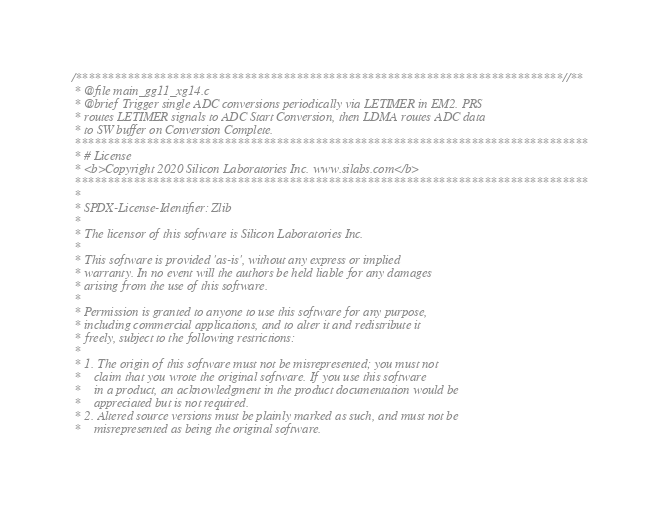<code> <loc_0><loc_0><loc_500><loc_500><_C_>/***************************************************************************//**
 * @file main_gg11_xg14.c
 * @brief Trigger single ADC conversions periodically via LETIMER in EM2. PRS
 * routes LETIMER signals to ADC Start Conversion, then LDMA routes ADC data
 * to SW buffer on Conversion Complete.
 *******************************************************************************
 * # License
 * <b>Copyright 2020 Silicon Laboratories Inc. www.silabs.com</b>
 *******************************************************************************
 *
 * SPDX-License-Identifier: Zlib
 *
 * The licensor of this software is Silicon Laboratories Inc.
 *
 * This software is provided 'as-is', without any express or implied
 * warranty. In no event will the authors be held liable for any damages
 * arising from the use of this software.
 *
 * Permission is granted to anyone to use this software for any purpose,
 * including commercial applications, and to alter it and redistribute it
 * freely, subject to the following restrictions:
 *
 * 1. The origin of this software must not be misrepresented; you must not
 *    claim that you wrote the original software. If you use this software
 *    in a product, an acknowledgment in the product documentation would be
 *    appreciated but is not required.
 * 2. Altered source versions must be plainly marked as such, and must not be
 *    misrepresented as being the original software.</code> 